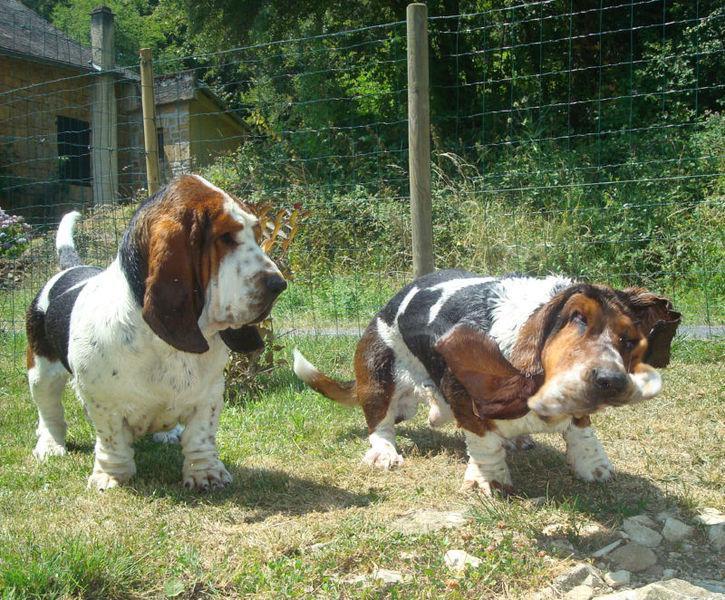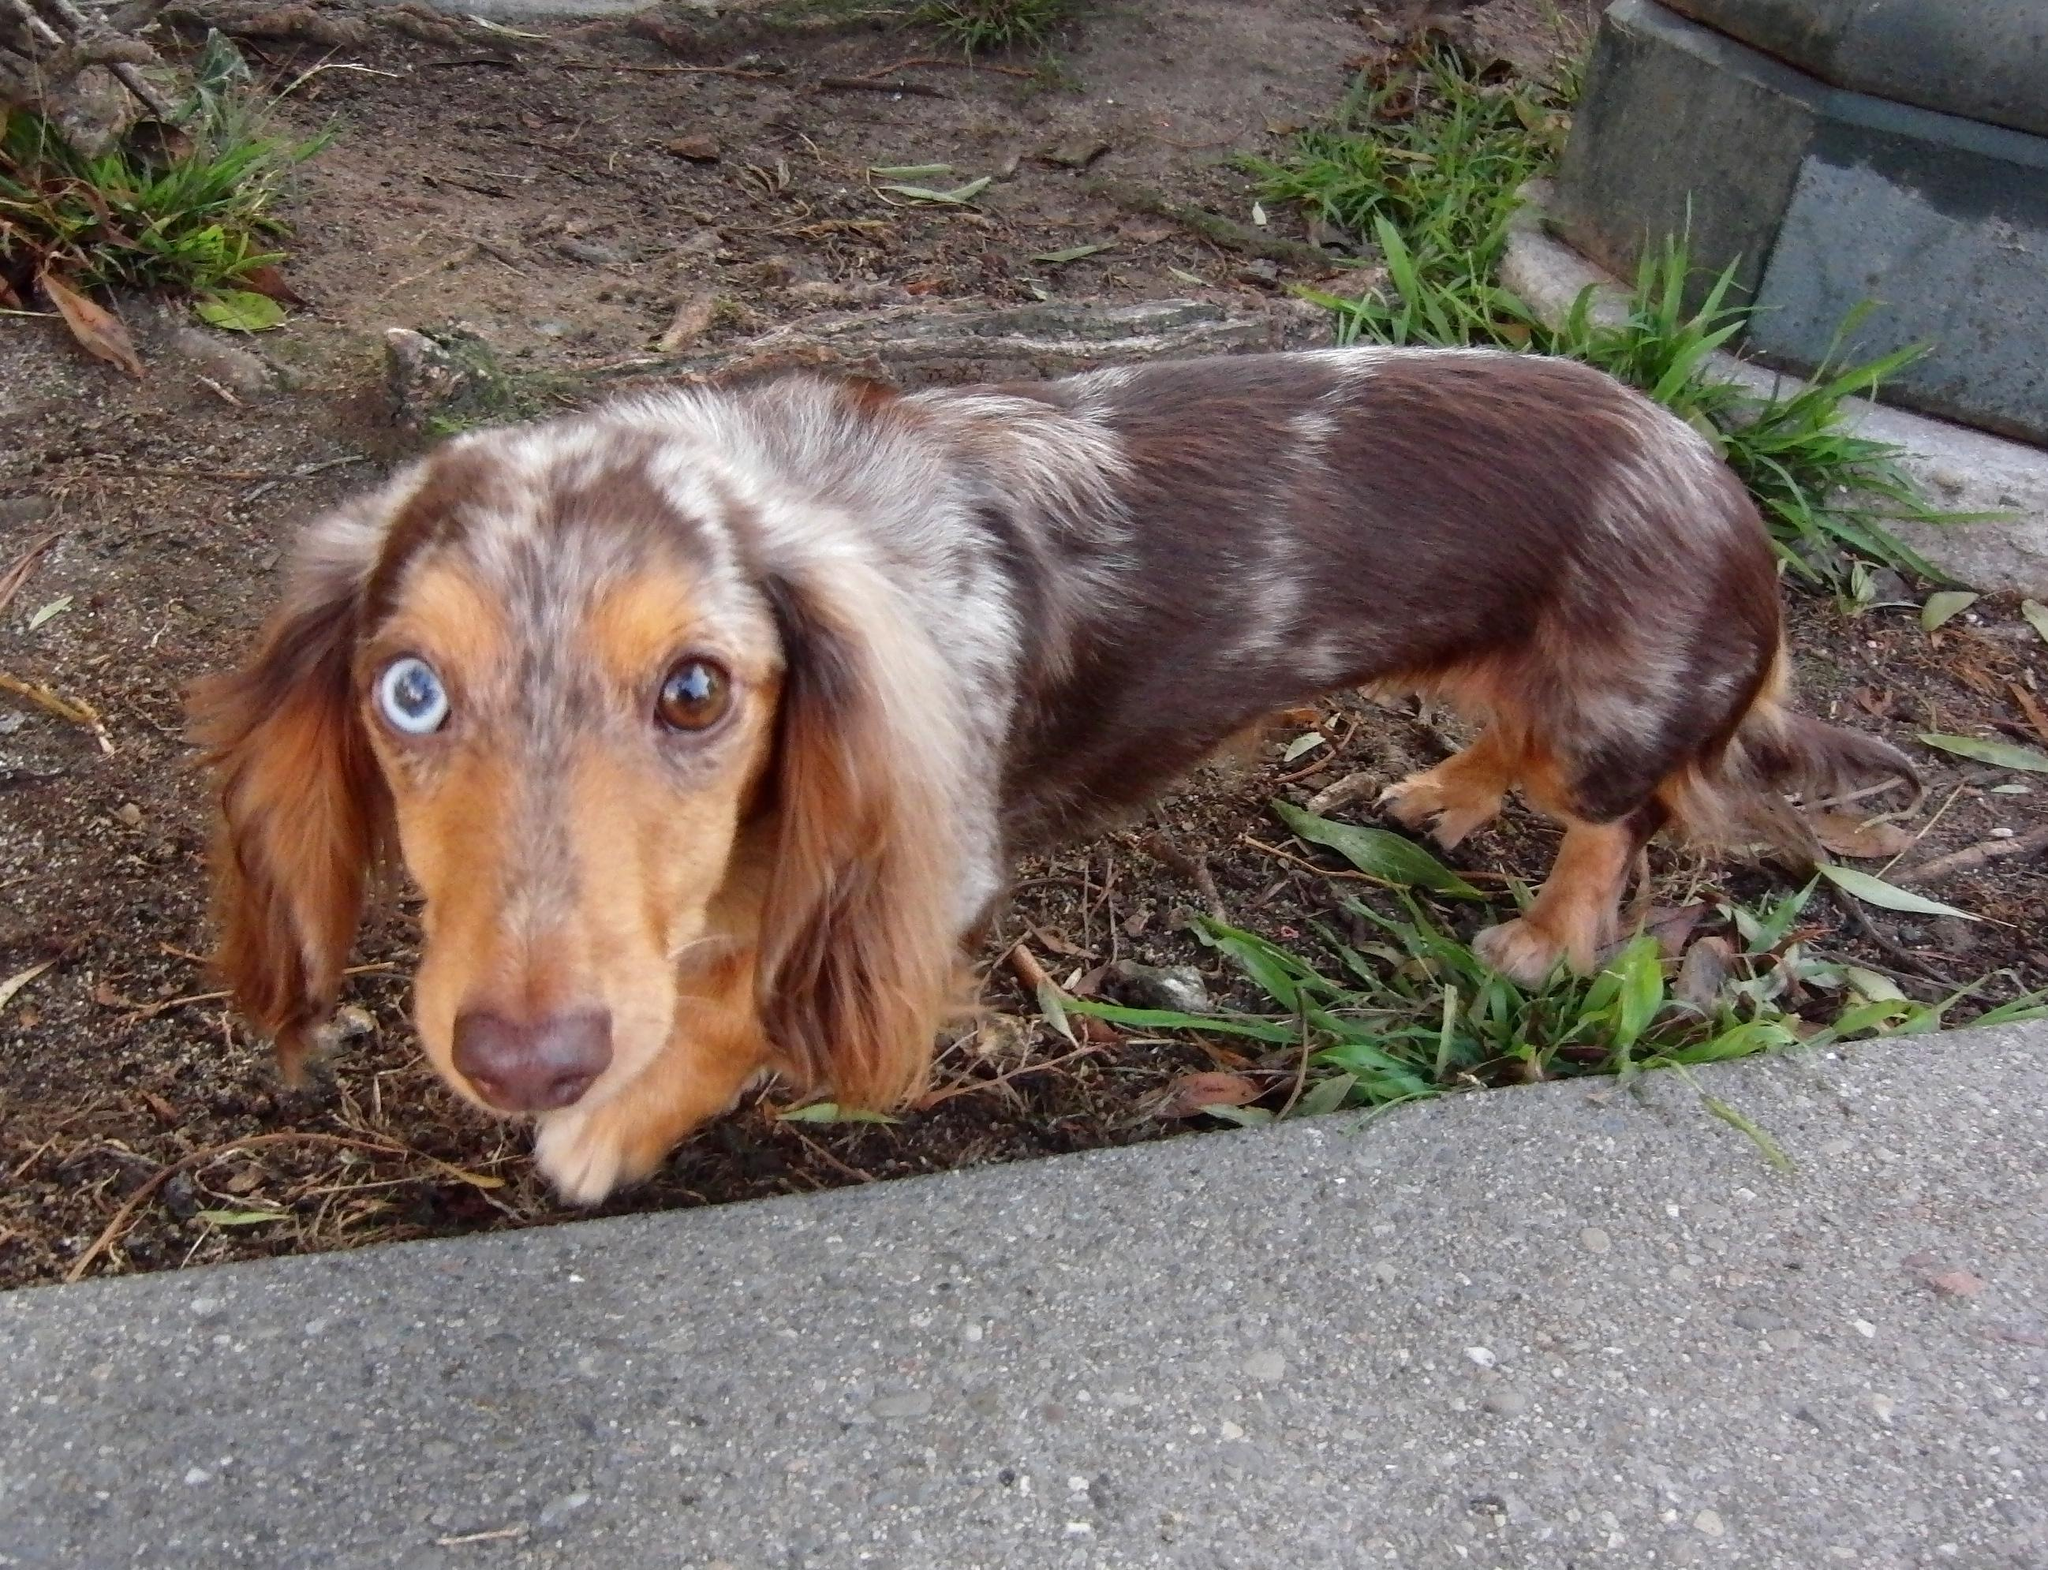The first image is the image on the left, the second image is the image on the right. Examine the images to the left and right. Is the description "There are three dogs." accurate? Answer yes or no. Yes. The first image is the image on the left, the second image is the image on the right. Examine the images to the left and right. Is the description "An image shows two basset hounds side-by-side outdoors, and at least one has its loose jowls flapping." accurate? Answer yes or no. Yes. 